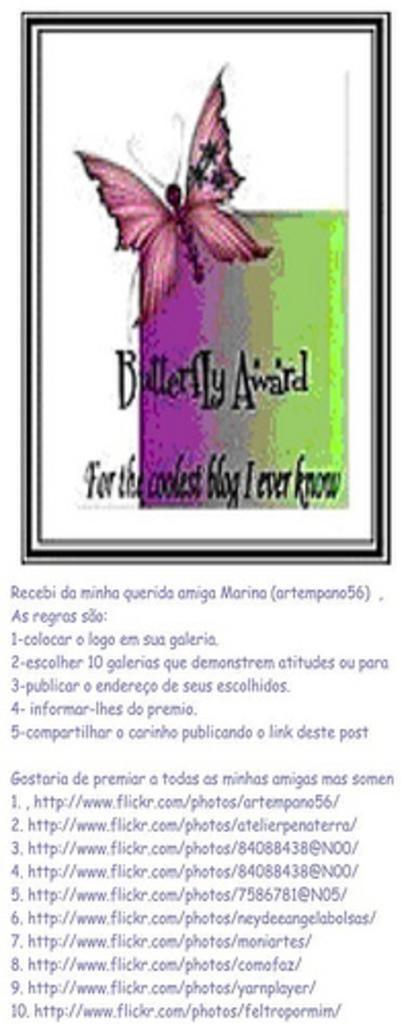What is the main object in the image? There is a frame in the image. What can be found within the frame? There is text and a butterfly inside the frame. Is there any text outside of the frame? Yes, there is text at the bottom of the image. What type of insurance is being advertised on the floor in the image? There is no floor or insurance advertisement present in the image. What is the zephyr's role in the image? There is no zephyr present in the image. 